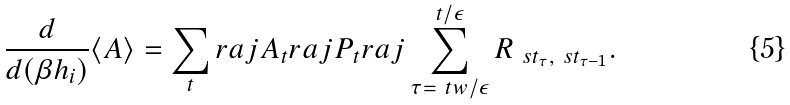Convert formula to latex. <formula><loc_0><loc_0><loc_500><loc_500>\frac { d } { d ( \beta h _ { i } ) } \langle A \rangle = \sum _ { t } r a j A _ { t } r a j P _ { t } r a j \sum _ { \tau = \ t w / \epsilon } ^ { t / \epsilon } R _ { \ s t _ { \tau } , \ s t _ { \tau - 1 } } .</formula> 